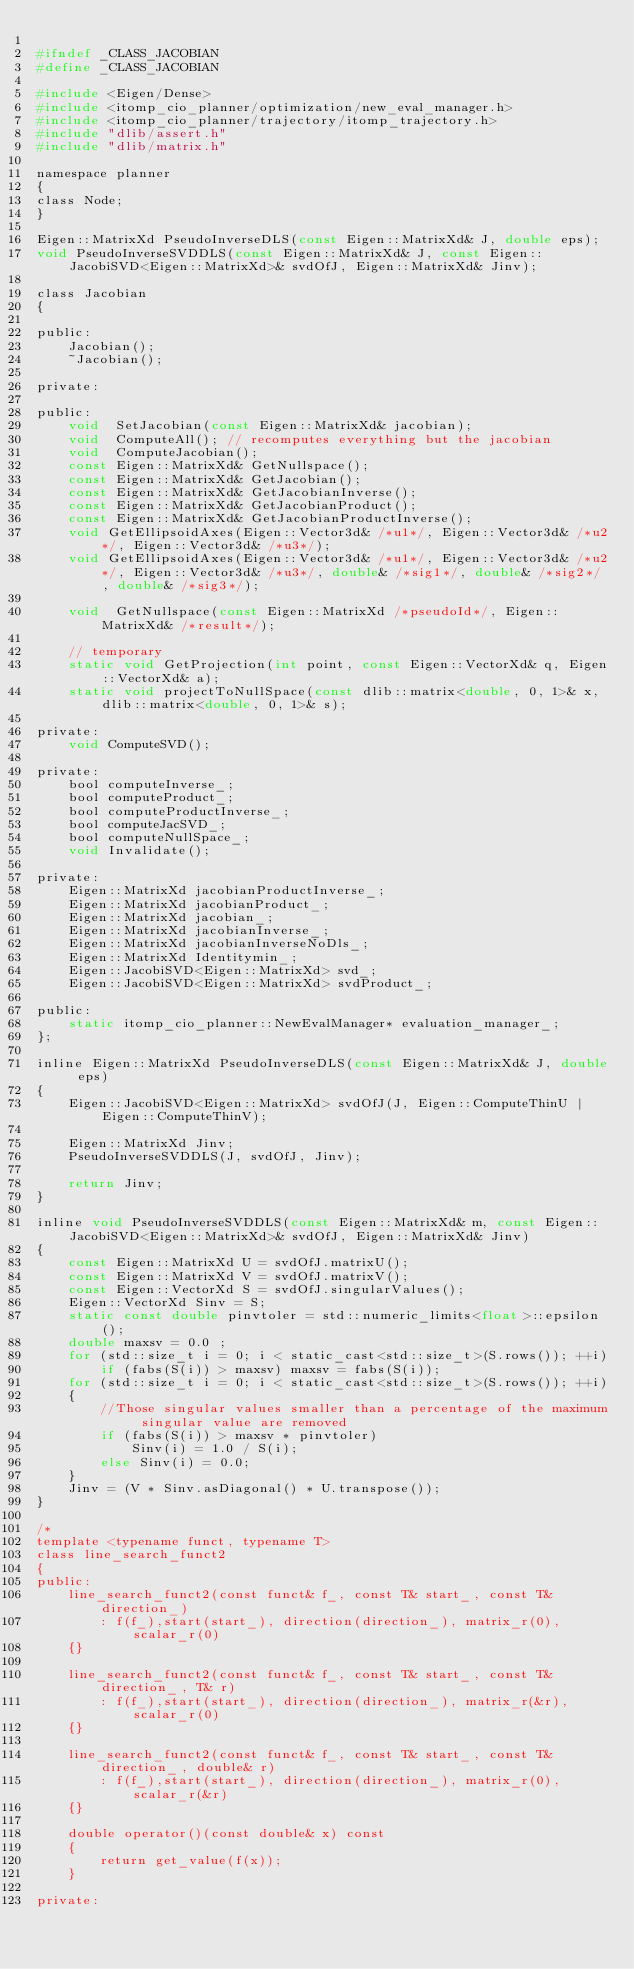Convert code to text. <code><loc_0><loc_0><loc_500><loc_500><_C_>
#ifndef _CLASS_JACOBIAN
#define _CLASS_JACOBIAN

#include <Eigen/Dense>
#include <itomp_cio_planner/optimization/new_eval_manager.h>
#include <itomp_cio_planner/trajectory/itomp_trajectory.h>
#include "dlib/assert.h"
#include "dlib/matrix.h"

namespace planner
{
class Node;
}

Eigen::MatrixXd PseudoInverseDLS(const Eigen::MatrixXd& J, double eps);
void PseudoInverseSVDDLS(const Eigen::MatrixXd& J, const Eigen::JacobiSVD<Eigen::MatrixXd>& svdOfJ, Eigen::MatrixXd& Jinv);

class Jacobian
{

public:
	Jacobian();
	~Jacobian();

private:

public:
	void  SetJacobian(const Eigen::MatrixXd& jacobian);
	void  ComputeAll(); // recomputes everything but the jacobian
	void  ComputeJacobian();
	const Eigen::MatrixXd& GetNullspace();
	const Eigen::MatrixXd& GetJacobian();
	const Eigen::MatrixXd& GetJacobianInverse();
	const Eigen::MatrixXd& GetJacobianProduct();
	const Eigen::MatrixXd& GetJacobianProductInverse();
	void GetEllipsoidAxes(Eigen::Vector3d& /*u1*/, Eigen::Vector3d& /*u2*/, Eigen::Vector3d& /*u3*/);
	void GetEllipsoidAxes(Eigen::Vector3d& /*u1*/, Eigen::Vector3d& /*u2*/, Eigen::Vector3d& /*u3*/, double& /*sig1*/, double& /*sig2*/, double& /*sig3*/);

	void  GetNullspace(const Eigen::MatrixXd /*pseudoId*/, Eigen::MatrixXd& /*result*/);

	// temporary
	static void GetProjection(int point, const Eigen::VectorXd& q, Eigen::VectorXd& a);
    static void projectToNullSpace(const dlib::matrix<double, 0, 1>& x, dlib::matrix<double, 0, 1>& s);

private:
	void ComputeSVD();

private:
	bool computeInverse_;
	bool computeProduct_;
	bool computeProductInverse_;
	bool computeJacSVD_;
	bool computeNullSpace_;
	void Invalidate();

private:
	Eigen::MatrixXd jacobianProductInverse_;
	Eigen::MatrixXd jacobianProduct_;
	Eigen::MatrixXd jacobian_;
	Eigen::MatrixXd jacobianInverse_;
	Eigen::MatrixXd jacobianInverseNoDls_;
	Eigen::MatrixXd Identitymin_;
	Eigen::JacobiSVD<Eigen::MatrixXd> svd_;
	Eigen::JacobiSVD<Eigen::MatrixXd> svdProduct_;

public:
	static itomp_cio_planner::NewEvalManager* evaluation_manager_;
};

inline Eigen::MatrixXd PseudoInverseDLS(const Eigen::MatrixXd& J, double eps)
{
	Eigen::JacobiSVD<Eigen::MatrixXd> svdOfJ(J, Eigen::ComputeThinU | Eigen::ComputeThinV);

	Eigen::MatrixXd Jinv;
	PseudoInverseSVDDLS(J, svdOfJ, Jinv);

	return Jinv;
}

inline void PseudoInverseSVDDLS(const Eigen::MatrixXd& m, const Eigen::JacobiSVD<Eigen::MatrixXd>& svdOfJ, Eigen::MatrixXd& Jinv)
{
	const Eigen::MatrixXd U = svdOfJ.matrixU();
	const Eigen::MatrixXd V = svdOfJ.matrixV();
	const Eigen::VectorXd S = svdOfJ.singularValues();
	Eigen::VectorXd Sinv = S;
	static const double pinvtoler = std::numeric_limits<float>::epsilon();
	double maxsv = 0.0 ;
	for (std::size_t i = 0; i < static_cast<std::size_t>(S.rows()); ++i)
		if (fabs(S(i)) > maxsv) maxsv = fabs(S(i));
	for (std::size_t i = 0; i < static_cast<std::size_t>(S.rows()); ++i)
	{
		//Those singular values smaller than a percentage of the maximum singular value are removed
		if (fabs(S(i)) > maxsv * pinvtoler)
			Sinv(i) = 1.0 / S(i);
		else Sinv(i) = 0.0;
	}
	Jinv = (V * Sinv.asDiagonal() * U.transpose());
}

/*
template <typename funct, typename T>
class line_search_funct2
{
public:
    line_search_funct2(const funct& f_, const T& start_, const T& direction_)
        : f(f_),start(start_), direction(direction_), matrix_r(0), scalar_r(0)
    {}

    line_search_funct2(const funct& f_, const T& start_, const T& direction_, T& r)
        : f(f_),start(start_), direction(direction_), matrix_r(&r), scalar_r(0)
    {}

    line_search_funct2(const funct& f_, const T& start_, const T& direction_, double& r)
        : f(f_),start(start_), direction(direction_), matrix_r(0), scalar_r(&r)
    {}

    double operator()(const double& x) const
    {
        return get_value(f(x));
    }

private:
</code> 